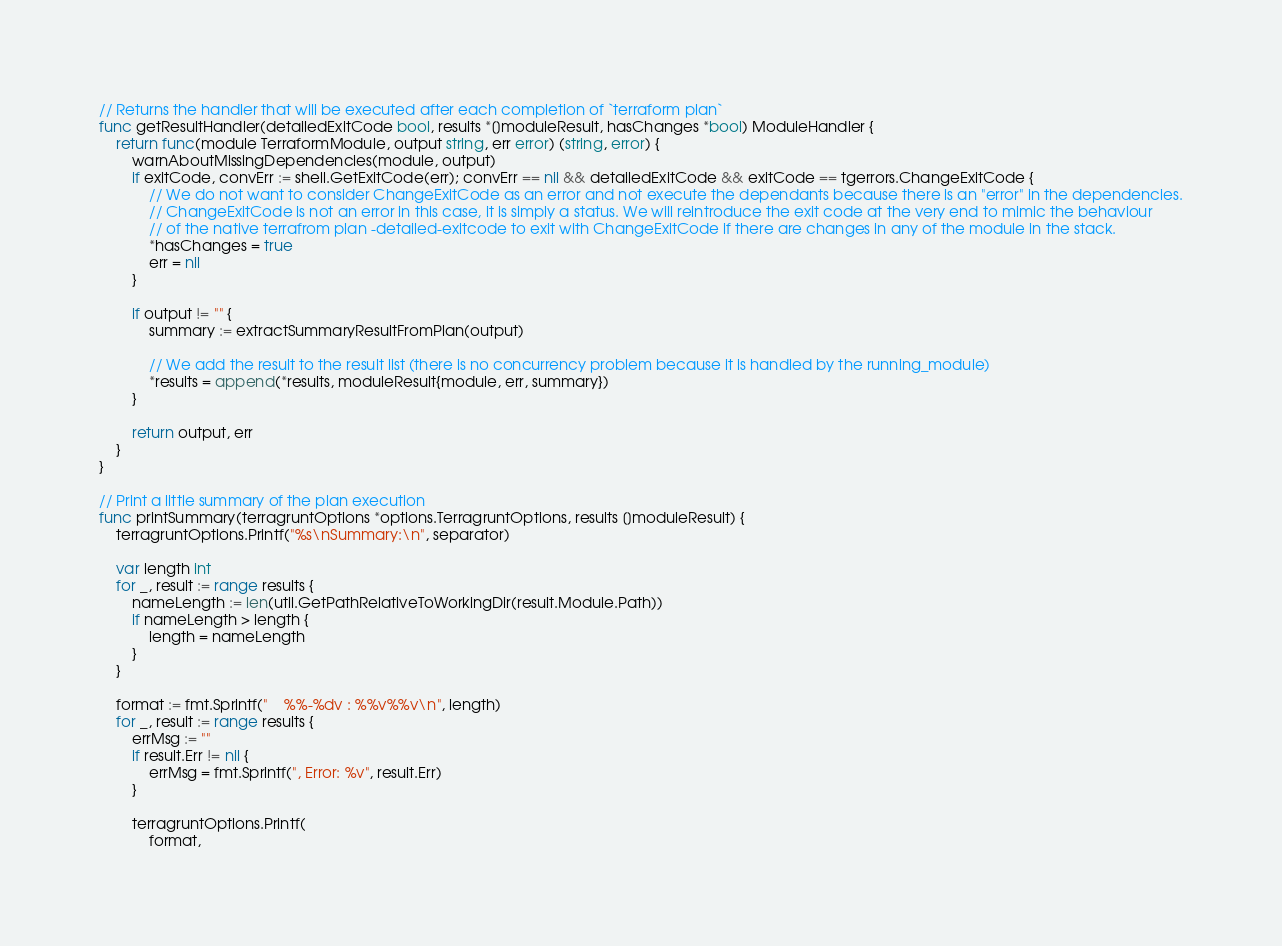Convert code to text. <code><loc_0><loc_0><loc_500><loc_500><_Go_>
// Returns the handler that will be executed after each completion of `terraform plan`
func getResultHandler(detailedExitCode bool, results *[]moduleResult, hasChanges *bool) ModuleHandler {
	return func(module TerraformModule, output string, err error) (string, error) {
		warnAboutMissingDependencies(module, output)
		if exitCode, convErr := shell.GetExitCode(err); convErr == nil && detailedExitCode && exitCode == tgerrors.ChangeExitCode {
			// We do not want to consider ChangeExitCode as an error and not execute the dependants because there is an "error" in the dependencies.
			// ChangeExitCode is not an error in this case, it is simply a status. We will reintroduce the exit code at the very end to mimic the behaviour
			// of the native terrafrom plan -detailed-exitcode to exit with ChangeExitCode if there are changes in any of the module in the stack.
			*hasChanges = true
			err = nil
		}

		if output != "" {
			summary := extractSummaryResultFromPlan(output)

			// We add the result to the result list (there is no concurrency problem because it is handled by the running_module)
			*results = append(*results, moduleResult{module, err, summary})
		}

		return output, err
	}
}

// Print a little summary of the plan execution
func printSummary(terragruntOptions *options.TerragruntOptions, results []moduleResult) {
	terragruntOptions.Printf("%s\nSummary:\n", separator)

	var length int
	for _, result := range results {
		nameLength := len(util.GetPathRelativeToWorkingDir(result.Module.Path))
		if nameLength > length {
			length = nameLength
		}
	}

	format := fmt.Sprintf("    %%-%dv : %%v%%v\n", length)
	for _, result := range results {
		errMsg := ""
		if result.Err != nil {
			errMsg = fmt.Sprintf(", Error: %v", result.Err)
		}

		terragruntOptions.Printf(
			format,</code> 